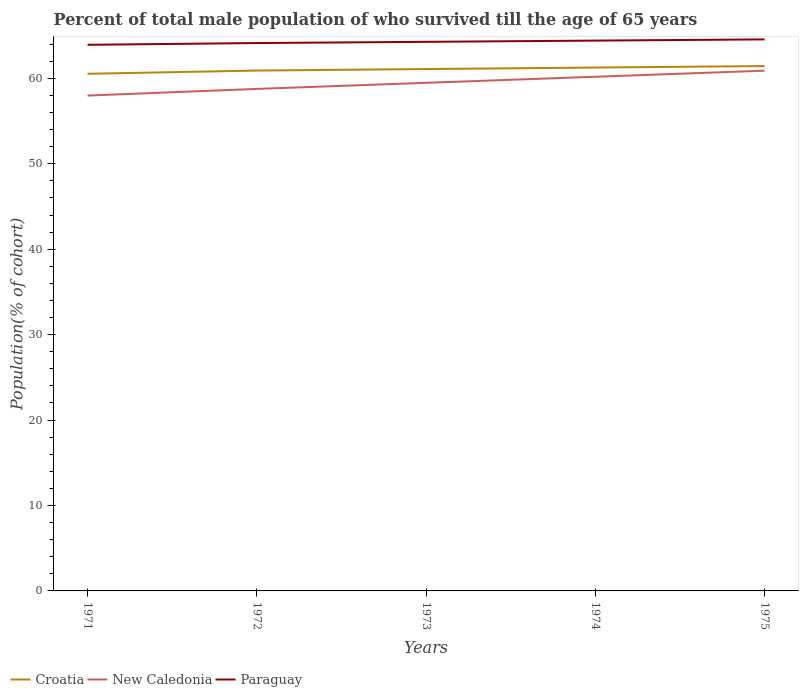How many different coloured lines are there?
Your answer should be compact. 3. Across all years, what is the maximum percentage of total male population who survived till the age of 65 years in New Caledonia?
Ensure brevity in your answer.  57.99. In which year was the percentage of total male population who survived till the age of 65 years in Croatia maximum?
Make the answer very short. 1971. What is the total percentage of total male population who survived till the age of 65 years in New Caledonia in the graph?
Offer a very short reply. -0.71. What is the difference between the highest and the second highest percentage of total male population who survived till the age of 65 years in Paraguay?
Give a very brief answer. 0.64. How many years are there in the graph?
Your answer should be compact. 5. Does the graph contain grids?
Provide a short and direct response. No. How are the legend labels stacked?
Provide a succinct answer. Horizontal. What is the title of the graph?
Your response must be concise. Percent of total male population of who survived till the age of 65 years. Does "High income" appear as one of the legend labels in the graph?
Keep it short and to the point. No. What is the label or title of the Y-axis?
Make the answer very short. Population(% of cohort). What is the Population(% of cohort) of Croatia in 1971?
Offer a very short reply. 60.54. What is the Population(% of cohort) in New Caledonia in 1971?
Give a very brief answer. 57.99. What is the Population(% of cohort) of Paraguay in 1971?
Offer a very short reply. 63.93. What is the Population(% of cohort) of Croatia in 1972?
Provide a short and direct response. 60.92. What is the Population(% of cohort) in New Caledonia in 1972?
Your answer should be very brief. 58.77. What is the Population(% of cohort) of Paraguay in 1972?
Keep it short and to the point. 64.14. What is the Population(% of cohort) of Croatia in 1973?
Provide a short and direct response. 61.09. What is the Population(% of cohort) in New Caledonia in 1973?
Your answer should be compact. 59.48. What is the Population(% of cohort) of Paraguay in 1973?
Provide a short and direct response. 64.28. What is the Population(% of cohort) in Croatia in 1974?
Provide a short and direct response. 61.27. What is the Population(% of cohort) in New Caledonia in 1974?
Ensure brevity in your answer.  60.19. What is the Population(% of cohort) of Paraguay in 1974?
Offer a very short reply. 64.42. What is the Population(% of cohort) in Croatia in 1975?
Your answer should be compact. 61.44. What is the Population(% of cohort) of New Caledonia in 1975?
Keep it short and to the point. 60.9. What is the Population(% of cohort) in Paraguay in 1975?
Ensure brevity in your answer.  64.56. Across all years, what is the maximum Population(% of cohort) in Croatia?
Ensure brevity in your answer.  61.44. Across all years, what is the maximum Population(% of cohort) in New Caledonia?
Provide a succinct answer. 60.9. Across all years, what is the maximum Population(% of cohort) of Paraguay?
Your answer should be compact. 64.56. Across all years, what is the minimum Population(% of cohort) of Croatia?
Provide a succinct answer. 60.54. Across all years, what is the minimum Population(% of cohort) in New Caledonia?
Give a very brief answer. 57.99. Across all years, what is the minimum Population(% of cohort) in Paraguay?
Offer a terse response. 63.93. What is the total Population(% of cohort) of Croatia in the graph?
Offer a terse response. 305.25. What is the total Population(% of cohort) in New Caledonia in the graph?
Offer a terse response. 297.32. What is the total Population(% of cohort) in Paraguay in the graph?
Ensure brevity in your answer.  321.33. What is the difference between the Population(% of cohort) in Croatia in 1971 and that in 1972?
Ensure brevity in your answer.  -0.38. What is the difference between the Population(% of cohort) of New Caledonia in 1971 and that in 1972?
Provide a succinct answer. -0.78. What is the difference between the Population(% of cohort) in Paraguay in 1971 and that in 1972?
Provide a succinct answer. -0.21. What is the difference between the Population(% of cohort) in Croatia in 1971 and that in 1973?
Provide a succinct answer. -0.55. What is the difference between the Population(% of cohort) of New Caledonia in 1971 and that in 1973?
Offer a terse response. -1.49. What is the difference between the Population(% of cohort) in Paraguay in 1971 and that in 1973?
Make the answer very short. -0.35. What is the difference between the Population(% of cohort) of Croatia in 1971 and that in 1974?
Your response must be concise. -0.73. What is the difference between the Population(% of cohort) of New Caledonia in 1971 and that in 1974?
Keep it short and to the point. -2.2. What is the difference between the Population(% of cohort) in Paraguay in 1971 and that in 1974?
Your response must be concise. -0.49. What is the difference between the Population(% of cohort) of Croatia in 1971 and that in 1975?
Your response must be concise. -0.91. What is the difference between the Population(% of cohort) of New Caledonia in 1971 and that in 1975?
Provide a short and direct response. -2.91. What is the difference between the Population(% of cohort) of Paraguay in 1971 and that in 1975?
Your answer should be very brief. -0.64. What is the difference between the Population(% of cohort) in Croatia in 1972 and that in 1973?
Your response must be concise. -0.18. What is the difference between the Population(% of cohort) in New Caledonia in 1972 and that in 1973?
Your answer should be compact. -0.71. What is the difference between the Population(% of cohort) of Paraguay in 1972 and that in 1973?
Provide a succinct answer. -0.14. What is the difference between the Population(% of cohort) of Croatia in 1972 and that in 1974?
Offer a very short reply. -0.35. What is the difference between the Population(% of cohort) in New Caledonia in 1972 and that in 1974?
Your response must be concise. -1.42. What is the difference between the Population(% of cohort) in Paraguay in 1972 and that in 1974?
Offer a very short reply. -0.29. What is the difference between the Population(% of cohort) of Croatia in 1972 and that in 1975?
Offer a very short reply. -0.53. What is the difference between the Population(% of cohort) of New Caledonia in 1972 and that in 1975?
Make the answer very short. -2.13. What is the difference between the Population(% of cohort) in Paraguay in 1972 and that in 1975?
Make the answer very short. -0.43. What is the difference between the Population(% of cohort) in Croatia in 1973 and that in 1974?
Offer a terse response. -0.18. What is the difference between the Population(% of cohort) of New Caledonia in 1973 and that in 1974?
Offer a very short reply. -0.71. What is the difference between the Population(% of cohort) in Paraguay in 1973 and that in 1974?
Your response must be concise. -0.14. What is the difference between the Population(% of cohort) of Croatia in 1973 and that in 1975?
Ensure brevity in your answer.  -0.35. What is the difference between the Population(% of cohort) in New Caledonia in 1973 and that in 1975?
Your response must be concise. -1.42. What is the difference between the Population(% of cohort) in Paraguay in 1973 and that in 1975?
Your response must be concise. -0.29. What is the difference between the Population(% of cohort) in Croatia in 1974 and that in 1975?
Keep it short and to the point. -0.18. What is the difference between the Population(% of cohort) in New Caledonia in 1974 and that in 1975?
Your answer should be very brief. -0.71. What is the difference between the Population(% of cohort) of Paraguay in 1974 and that in 1975?
Offer a very short reply. -0.14. What is the difference between the Population(% of cohort) in Croatia in 1971 and the Population(% of cohort) in New Caledonia in 1972?
Give a very brief answer. 1.77. What is the difference between the Population(% of cohort) in Croatia in 1971 and the Population(% of cohort) in Paraguay in 1972?
Give a very brief answer. -3.6. What is the difference between the Population(% of cohort) in New Caledonia in 1971 and the Population(% of cohort) in Paraguay in 1972?
Your response must be concise. -6.15. What is the difference between the Population(% of cohort) in Croatia in 1971 and the Population(% of cohort) in New Caledonia in 1973?
Offer a terse response. 1.06. What is the difference between the Population(% of cohort) in Croatia in 1971 and the Population(% of cohort) in Paraguay in 1973?
Your answer should be very brief. -3.74. What is the difference between the Population(% of cohort) in New Caledonia in 1971 and the Population(% of cohort) in Paraguay in 1973?
Offer a terse response. -6.29. What is the difference between the Population(% of cohort) of Croatia in 1971 and the Population(% of cohort) of New Caledonia in 1974?
Give a very brief answer. 0.35. What is the difference between the Population(% of cohort) in Croatia in 1971 and the Population(% of cohort) in Paraguay in 1974?
Make the answer very short. -3.88. What is the difference between the Population(% of cohort) in New Caledonia in 1971 and the Population(% of cohort) in Paraguay in 1974?
Your answer should be very brief. -6.44. What is the difference between the Population(% of cohort) of Croatia in 1971 and the Population(% of cohort) of New Caledonia in 1975?
Your answer should be very brief. -0.36. What is the difference between the Population(% of cohort) of Croatia in 1971 and the Population(% of cohort) of Paraguay in 1975?
Ensure brevity in your answer.  -4.03. What is the difference between the Population(% of cohort) of New Caledonia in 1971 and the Population(% of cohort) of Paraguay in 1975?
Your answer should be compact. -6.58. What is the difference between the Population(% of cohort) of Croatia in 1972 and the Population(% of cohort) of New Caledonia in 1973?
Ensure brevity in your answer.  1.44. What is the difference between the Population(% of cohort) of Croatia in 1972 and the Population(% of cohort) of Paraguay in 1973?
Offer a very short reply. -3.36. What is the difference between the Population(% of cohort) in New Caledonia in 1972 and the Population(% of cohort) in Paraguay in 1973?
Give a very brief answer. -5.51. What is the difference between the Population(% of cohort) of Croatia in 1972 and the Population(% of cohort) of New Caledonia in 1974?
Your response must be concise. 0.73. What is the difference between the Population(% of cohort) of Croatia in 1972 and the Population(% of cohort) of Paraguay in 1974?
Offer a very short reply. -3.51. What is the difference between the Population(% of cohort) in New Caledonia in 1972 and the Population(% of cohort) in Paraguay in 1974?
Your answer should be very brief. -5.65. What is the difference between the Population(% of cohort) in Croatia in 1972 and the Population(% of cohort) in New Caledonia in 1975?
Your answer should be very brief. 0.02. What is the difference between the Population(% of cohort) of Croatia in 1972 and the Population(% of cohort) of Paraguay in 1975?
Give a very brief answer. -3.65. What is the difference between the Population(% of cohort) of New Caledonia in 1972 and the Population(% of cohort) of Paraguay in 1975?
Offer a terse response. -5.79. What is the difference between the Population(% of cohort) in Croatia in 1973 and the Population(% of cohort) in New Caledonia in 1974?
Your answer should be very brief. 0.9. What is the difference between the Population(% of cohort) of Croatia in 1973 and the Population(% of cohort) of Paraguay in 1974?
Keep it short and to the point. -3.33. What is the difference between the Population(% of cohort) in New Caledonia in 1973 and the Population(% of cohort) in Paraguay in 1974?
Your answer should be compact. -4.94. What is the difference between the Population(% of cohort) of Croatia in 1973 and the Population(% of cohort) of New Caledonia in 1975?
Keep it short and to the point. 0.19. What is the difference between the Population(% of cohort) of Croatia in 1973 and the Population(% of cohort) of Paraguay in 1975?
Offer a terse response. -3.47. What is the difference between the Population(% of cohort) of New Caledonia in 1973 and the Population(% of cohort) of Paraguay in 1975?
Your answer should be very brief. -5.08. What is the difference between the Population(% of cohort) in Croatia in 1974 and the Population(% of cohort) in New Caledonia in 1975?
Make the answer very short. 0.37. What is the difference between the Population(% of cohort) in Croatia in 1974 and the Population(% of cohort) in Paraguay in 1975?
Your answer should be compact. -3.3. What is the difference between the Population(% of cohort) of New Caledonia in 1974 and the Population(% of cohort) of Paraguay in 1975?
Give a very brief answer. -4.37. What is the average Population(% of cohort) in Croatia per year?
Your answer should be very brief. 61.05. What is the average Population(% of cohort) in New Caledonia per year?
Provide a short and direct response. 59.46. What is the average Population(% of cohort) in Paraguay per year?
Give a very brief answer. 64.27. In the year 1971, what is the difference between the Population(% of cohort) of Croatia and Population(% of cohort) of New Caledonia?
Provide a succinct answer. 2.55. In the year 1971, what is the difference between the Population(% of cohort) of Croatia and Population(% of cohort) of Paraguay?
Provide a short and direct response. -3.39. In the year 1971, what is the difference between the Population(% of cohort) of New Caledonia and Population(% of cohort) of Paraguay?
Offer a terse response. -5.94. In the year 1972, what is the difference between the Population(% of cohort) in Croatia and Population(% of cohort) in New Caledonia?
Your response must be concise. 2.15. In the year 1972, what is the difference between the Population(% of cohort) of Croatia and Population(% of cohort) of Paraguay?
Ensure brevity in your answer.  -3.22. In the year 1972, what is the difference between the Population(% of cohort) in New Caledonia and Population(% of cohort) in Paraguay?
Keep it short and to the point. -5.37. In the year 1973, what is the difference between the Population(% of cohort) of Croatia and Population(% of cohort) of New Caledonia?
Offer a very short reply. 1.61. In the year 1973, what is the difference between the Population(% of cohort) in Croatia and Population(% of cohort) in Paraguay?
Ensure brevity in your answer.  -3.19. In the year 1973, what is the difference between the Population(% of cohort) in New Caledonia and Population(% of cohort) in Paraguay?
Make the answer very short. -4.8. In the year 1974, what is the difference between the Population(% of cohort) of Croatia and Population(% of cohort) of New Caledonia?
Your response must be concise. 1.08. In the year 1974, what is the difference between the Population(% of cohort) in Croatia and Population(% of cohort) in Paraguay?
Give a very brief answer. -3.15. In the year 1974, what is the difference between the Population(% of cohort) in New Caledonia and Population(% of cohort) in Paraguay?
Your answer should be compact. -4.23. In the year 1975, what is the difference between the Population(% of cohort) in Croatia and Population(% of cohort) in New Caledonia?
Give a very brief answer. 0.54. In the year 1975, what is the difference between the Population(% of cohort) in Croatia and Population(% of cohort) in Paraguay?
Your answer should be very brief. -3.12. In the year 1975, what is the difference between the Population(% of cohort) of New Caledonia and Population(% of cohort) of Paraguay?
Your response must be concise. -3.66. What is the ratio of the Population(% of cohort) in Croatia in 1971 to that in 1972?
Your answer should be compact. 0.99. What is the ratio of the Population(% of cohort) of New Caledonia in 1971 to that in 1972?
Ensure brevity in your answer.  0.99. What is the ratio of the Population(% of cohort) of Paraguay in 1971 to that in 1972?
Offer a very short reply. 1. What is the ratio of the Population(% of cohort) in Croatia in 1971 to that in 1973?
Give a very brief answer. 0.99. What is the ratio of the Population(% of cohort) of New Caledonia in 1971 to that in 1973?
Provide a short and direct response. 0.97. What is the ratio of the Population(% of cohort) of New Caledonia in 1971 to that in 1974?
Your answer should be compact. 0.96. What is the ratio of the Population(% of cohort) in Croatia in 1971 to that in 1975?
Provide a short and direct response. 0.99. What is the ratio of the Population(% of cohort) in New Caledonia in 1971 to that in 1975?
Your answer should be compact. 0.95. What is the ratio of the Population(% of cohort) in Paraguay in 1971 to that in 1975?
Offer a very short reply. 0.99. What is the ratio of the Population(% of cohort) in Croatia in 1972 to that in 1973?
Keep it short and to the point. 1. What is the ratio of the Population(% of cohort) of Paraguay in 1972 to that in 1973?
Offer a terse response. 1. What is the ratio of the Population(% of cohort) of Croatia in 1972 to that in 1974?
Offer a very short reply. 0.99. What is the ratio of the Population(% of cohort) in New Caledonia in 1972 to that in 1974?
Your answer should be compact. 0.98. What is the ratio of the Population(% of cohort) of Croatia in 1972 to that in 1975?
Make the answer very short. 0.99. What is the ratio of the Population(% of cohort) of New Caledonia in 1972 to that in 1975?
Keep it short and to the point. 0.96. What is the ratio of the Population(% of cohort) of Paraguay in 1972 to that in 1975?
Keep it short and to the point. 0.99. What is the ratio of the Population(% of cohort) of Paraguay in 1973 to that in 1974?
Keep it short and to the point. 1. What is the ratio of the Population(% of cohort) in Croatia in 1973 to that in 1975?
Your answer should be very brief. 0.99. What is the ratio of the Population(% of cohort) of New Caledonia in 1973 to that in 1975?
Your answer should be compact. 0.98. What is the ratio of the Population(% of cohort) of Paraguay in 1973 to that in 1975?
Ensure brevity in your answer.  1. What is the ratio of the Population(% of cohort) in New Caledonia in 1974 to that in 1975?
Your answer should be compact. 0.99. What is the ratio of the Population(% of cohort) of Paraguay in 1974 to that in 1975?
Offer a very short reply. 1. What is the difference between the highest and the second highest Population(% of cohort) in Croatia?
Your answer should be very brief. 0.18. What is the difference between the highest and the second highest Population(% of cohort) in New Caledonia?
Make the answer very short. 0.71. What is the difference between the highest and the second highest Population(% of cohort) in Paraguay?
Give a very brief answer. 0.14. What is the difference between the highest and the lowest Population(% of cohort) in Croatia?
Keep it short and to the point. 0.91. What is the difference between the highest and the lowest Population(% of cohort) in New Caledonia?
Offer a very short reply. 2.91. What is the difference between the highest and the lowest Population(% of cohort) in Paraguay?
Provide a succinct answer. 0.64. 